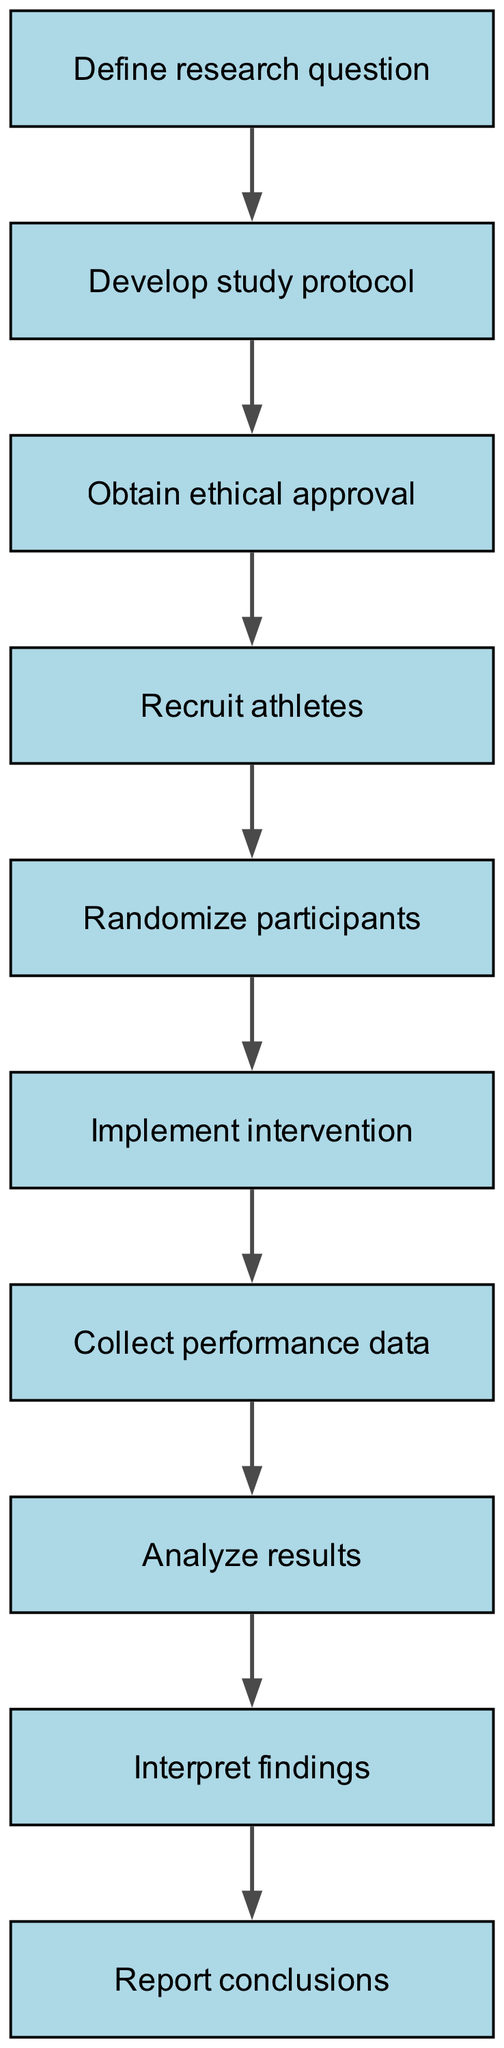What is the first step in the process? The first step in the flowchart is listed at the top, which is "Define research question". This is the starting point in the sequence of steps for conducting a randomized controlled trial in sports nutrition.
Answer: Define research question How many total steps are there in the diagram? By counting each entry within the steps list, there are ten individual steps present in the flowchart that describe the process.
Answer: 10 What step follows "Recruit athletes"? "Randomize participants" is the step that directly follows "Recruit athletes", indicating the sequence of actions taken after recruitment.
Answer: Randomize participants In which step do researchers analyze the results? The step labeled "Analyze results" in the flowchart indicates when researchers will perform analysis after collecting data. It is the eighth step in the sequence.
Answer: Analyze results What is the last step in the process? The final step shown in the flowchart is "Report conclusions", which wraps up the entire trial process by summarizing findings.
Answer: Report conclusions Which two steps come before "Implement intervention"? The steps that precede "Implement intervention" are "Randomize participants" (fifth step) and "Obtain ethical approval" (third step). Recognizing the ordered flow leading up to the intervention provides a clear understanding of the process flow.
Answer: Randomize participants, Obtain ethical approval What happens immediately after data collection? Following the step "Collect performance data", the next action is "Analyze results", indicating that data analysis is the immediate subsequent task.
Answer: Analyze results Which step requires ethical approval before proceeding? The step called "Obtain ethical approval" necessitates ethical clearance before moving on to recruit athletes. It is crucial for ensuring that the study meets ethical standards.
Answer: Obtain ethical approval 